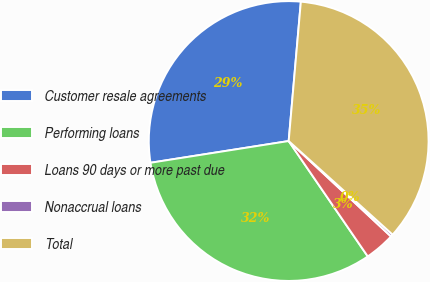<chart> <loc_0><loc_0><loc_500><loc_500><pie_chart><fcel>Customer resale agreements<fcel>Performing loans<fcel>Loans 90 days or more past due<fcel>Nonaccrual loans<fcel>Total<nl><fcel>28.87%<fcel>32.08%<fcel>3.49%<fcel>0.28%<fcel>35.28%<nl></chart> 